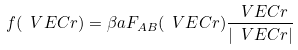<formula> <loc_0><loc_0><loc_500><loc_500>f ( \ V E C r ) = \beta a { F } _ { A B } ( \ V E C r ) \frac { \ V E C r } { | \ V E C r | }</formula> 